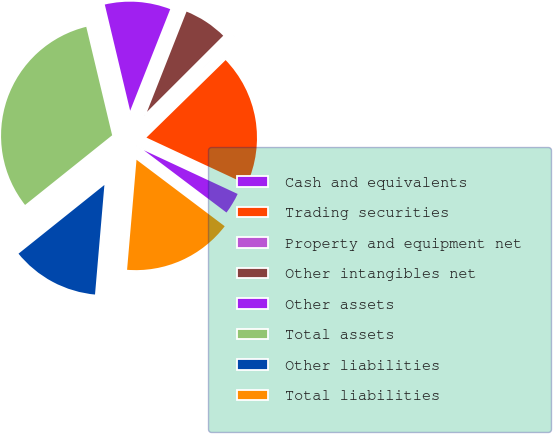<chart> <loc_0><loc_0><loc_500><loc_500><pie_chart><fcel>Cash and equivalents<fcel>Trading securities<fcel>Property and equipment net<fcel>Other intangibles net<fcel>Other assets<fcel>Total assets<fcel>Other liabilities<fcel>Total liabilities<nl><fcel>3.34%<fcel>19.27%<fcel>0.16%<fcel>6.53%<fcel>9.71%<fcel>32.01%<fcel>12.9%<fcel>16.08%<nl></chart> 